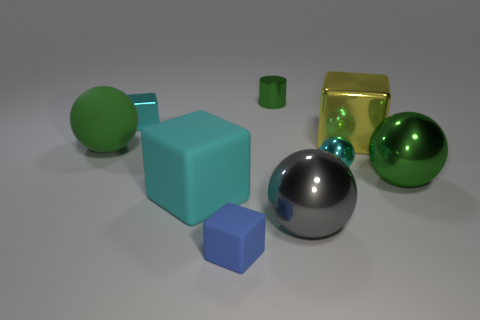There is a cyan metallic thing that is the same shape as the yellow metal object; what is its size?
Offer a very short reply. Small. What number of gray cylinders are the same material as the tiny ball?
Ensure brevity in your answer.  0. There is a big green ball right of the blue object; how many tiny metallic blocks are in front of it?
Offer a very short reply. 0. There is a big matte ball; are there any yellow objects on the left side of it?
Provide a succinct answer. No. There is a green metal thing that is to the left of the gray sphere; is it the same shape as the tiny rubber thing?
Offer a very short reply. No. What is the material of the large thing that is the same color as the large matte sphere?
Make the answer very short. Metal. How many other spheres are the same color as the big matte sphere?
Offer a very short reply. 1. There is a blue rubber object that is in front of the large cube that is to the left of the gray object; what is its shape?
Offer a terse response. Cube. Are there any other things that have the same shape as the cyan matte thing?
Provide a succinct answer. Yes. Is the color of the big rubber sphere the same as the matte thing that is in front of the cyan matte cube?
Provide a short and direct response. No. 